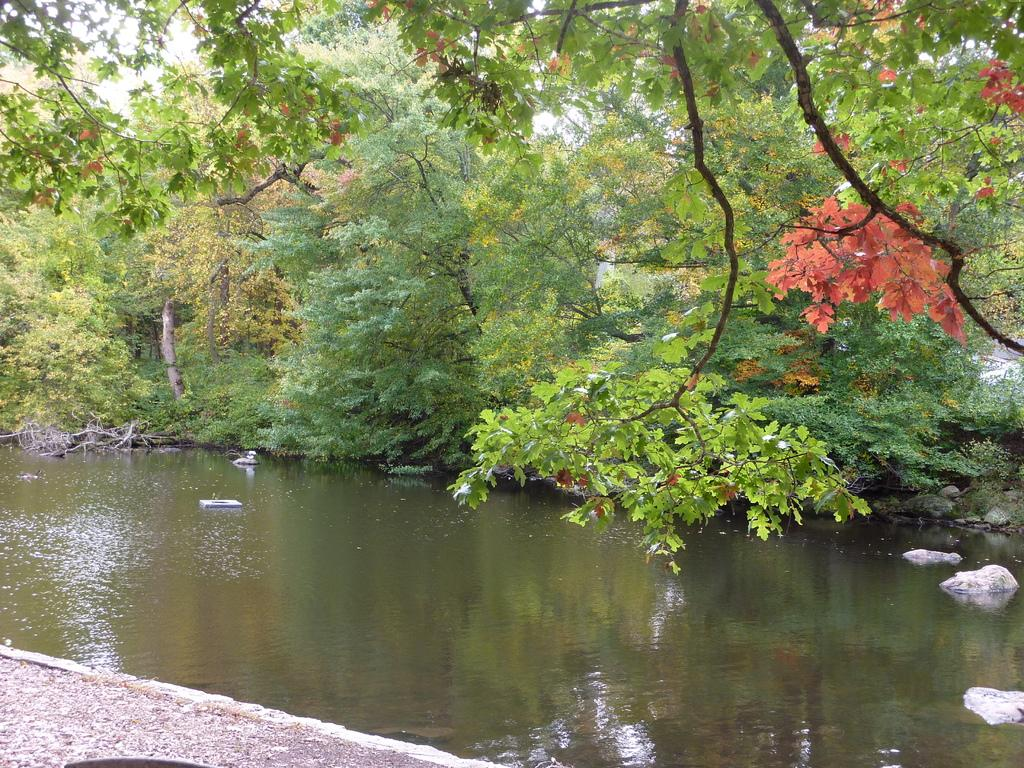What is located in the center of the image? There are trees, water, and rocks in the center of the image. What type of natural environment is depicted in the image? The image features a combination of trees, water, and rocks, which suggests a natural setting. What is visible at the bottom of the image? The ground is visible at the bottom of the image. What is visible at the top of the image? The sky is visible at the top of the image. What type of silver apple can be seen hanging from the trees in the image? There is no silver apple present in the image; it features trees, water, and rocks in a natural setting. 